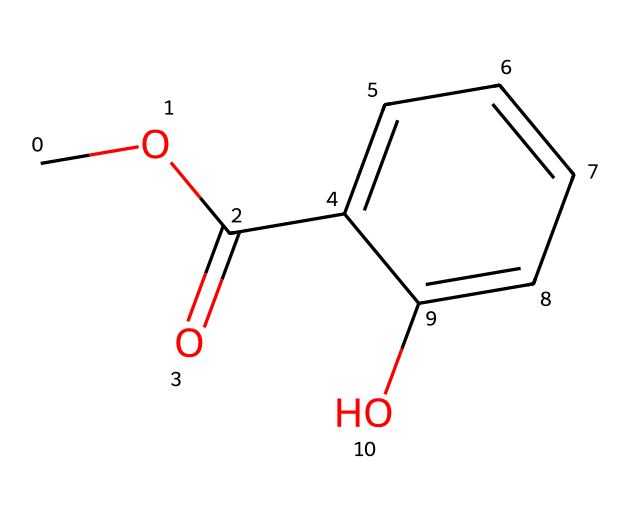What is the molecular formula of methyl salicylate? To find the molecular formula, we count the various atoms present in the structure: there are 9 carbon (C) atoms, 10 hydrogen (H) atoms, and 4 oxygen (O) atoms, leading to the molecular formula C9H10O4.
Answer: C9H10O4 How many double bonds are present in the structure? In the chemical structure, we can see one double bond between the carbonyl carbon and one oxygen (C=O) and one double bond in the aromatic ring. Hence, there are 2 double bonds in total.
Answer: 2 Which functional group is responsible for this compound being an ester? The -C(=O)O- structure denotes the presence of an ester functional group, as it combines a carbonyl (C=O) and an alkoxyl group (-O-).
Answer: ester What type of aroma is typically associated with methyl salicylate? Methyl salicylate is well known for its wintergreen scent, which is reminiscent of peppermint or spearmint.
Answer: wintergreen How many rings are present in the structure of methyl salicylate? Examining the structure shows there is one six-membered aromatic ring (benzene ring) in the structure.
Answer: 1 What common use does methyl salicylate have in sports? Methyl salicylate is commonly used in topical liniments and muscle rubs due to its analgesic properties, frequently utilized by athletes.
Answer: topical liniments 